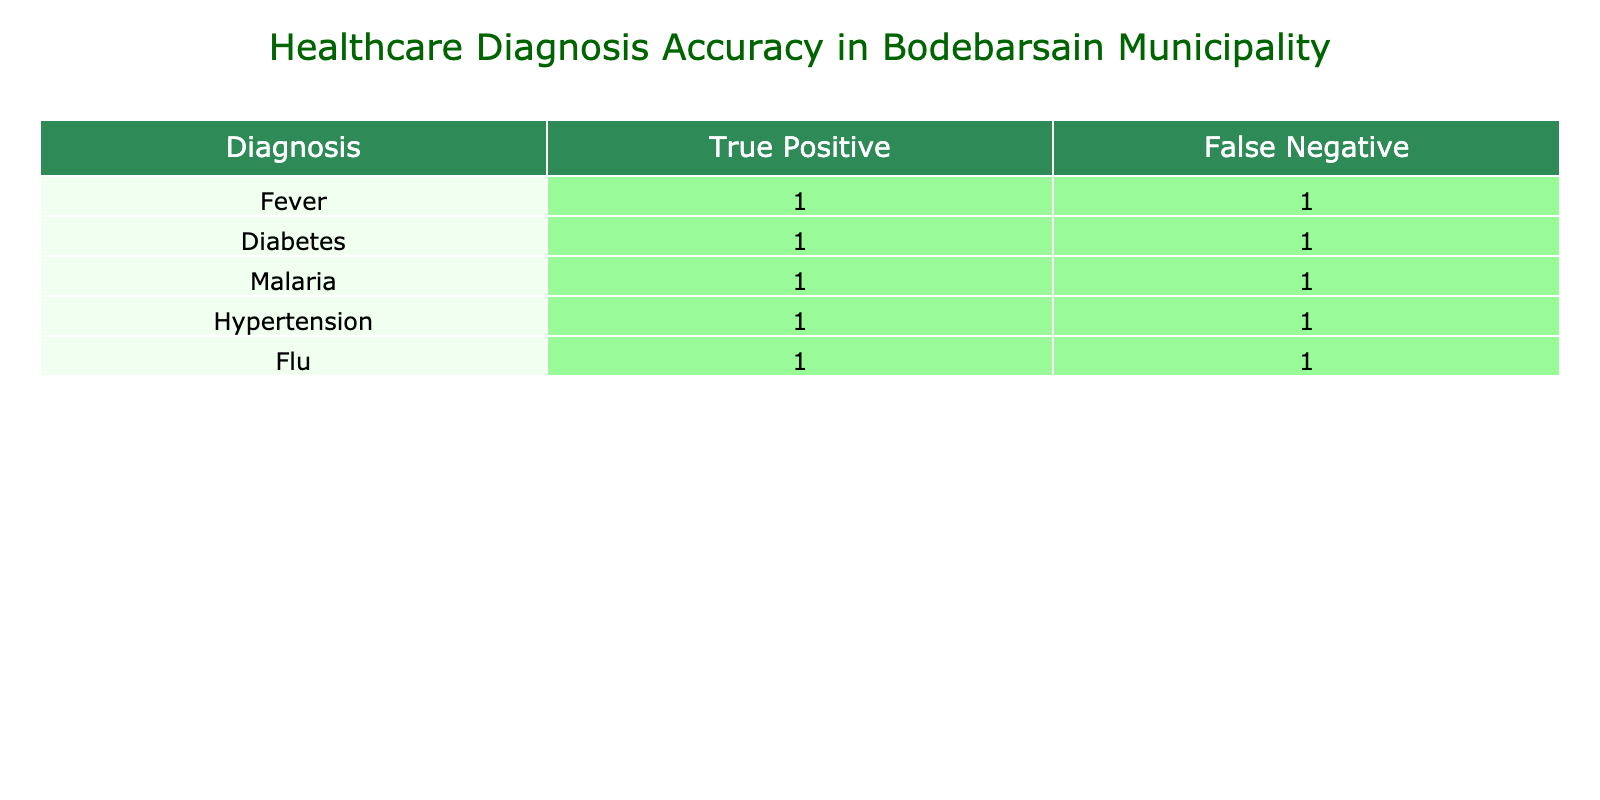What is the total number of True Positive diagnoses for Diabetes? There is one row for Diabetes in the table. The number of True Positive diagnoses is listed in the corresponding column for Diabetes. According to the table, there is one entry for True Positive under Diabetes. Hence, the answer is 1.
Answer: 1 How many total False Negatives are there for Malaria? The table contains one row for Malaria. To find the number of False Negatives, we look at the column labeled False Negative for Malaria. Based on the table, there is one entry for False Negative under Malaria, so the total is 1.
Answer: 1 Is there a higher number of True Positive diagnoses for Fever or Flu? We compare the True Positive diagnoses for Fever and Flu. In the table, Fever has 1 True Positive, and Flu also has 1 True Positive. Since both values are equal, there is not a higher number for either.
Answer: No What is the sum of True Positive diagnoses across all conditions? To find the sum of True Positive diagnoses, we add up the True Positive values for all the conditions in the table. Each condition (Fever, Diabetes, Malaria, Hypertension, Flu) contributes 1 True Positive. So, 1 (Fever) + 1 (Diabetes) + 1 (Malaria) + 1 (Hypertension) + 1 (Flu) = 5.
Answer: 5 Is Hypertension listed as having any False Positive diagnoses? The table lists data for Hypertension and shows the number of False Positives under that condition. According to the table, there are no entries for False Positive under Hypertension, indicating there are none.
Answer: No Which condition has the highest number of True Positive diagnoses? We check the True Positive numbers for all conditions in the table. Each condition (Fever, Diabetes, Malaria, Hypertension, Flu) has 1 True Positive. Therefore, there is no single condition with a higher count; they are all equal.
Answer: None What is the difference between True Positives and False Negatives for Fever? The table shows that Fever has 1 True Positive and 1 False Negative. To find the difference, we subtract the False Negatives from the True Positives: 1 (True Positive) - 1 (False Negative) = 0.
Answer: 0 How many conditions have both True Positives and False Negatives? We examine each condition in the table to check if both True Positives and False Negatives exist. Every condition listed has both entries, so the total count of conditions with both is 5.
Answer: 5 